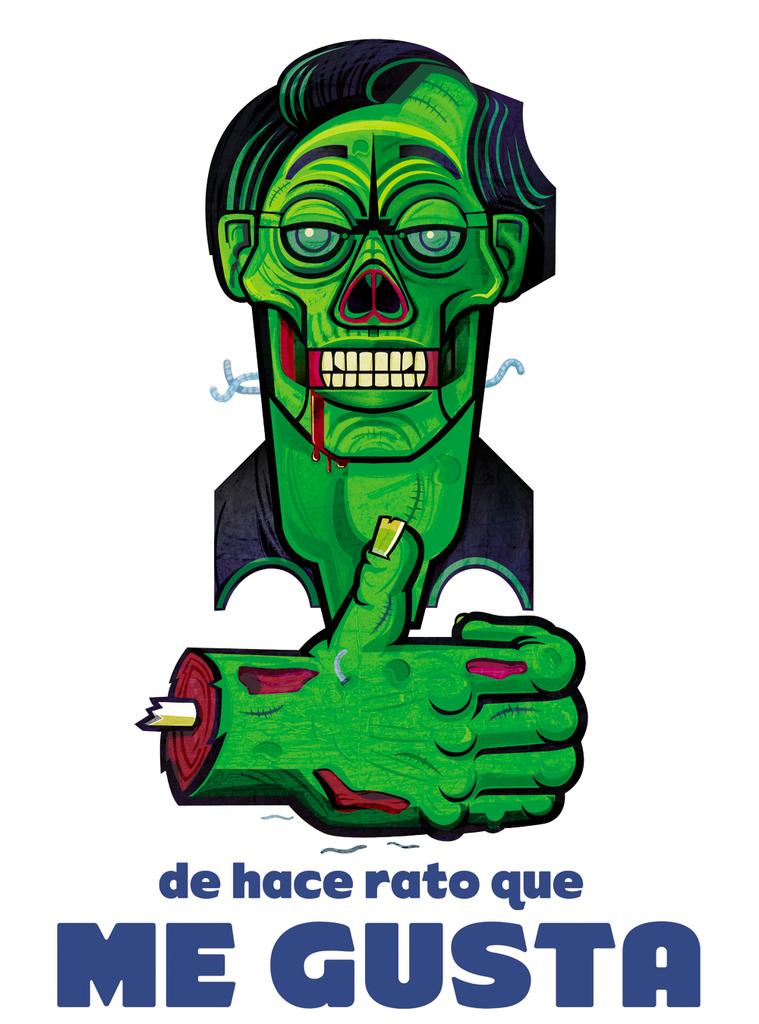Provide a one-sentence caption for the provided image. A picture of Frankenstein thatr reads Me Gusta underneath. 